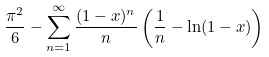Convert formula to latex. <formula><loc_0><loc_0><loc_500><loc_500>\frac { \pi ^ { 2 } } { 6 } - \sum _ { n = 1 } ^ { \infty } \frac { ( 1 - x ) ^ { n } } { n } \left ( \frac { 1 } { n } - \ln ( 1 - x ) \right )</formula> 